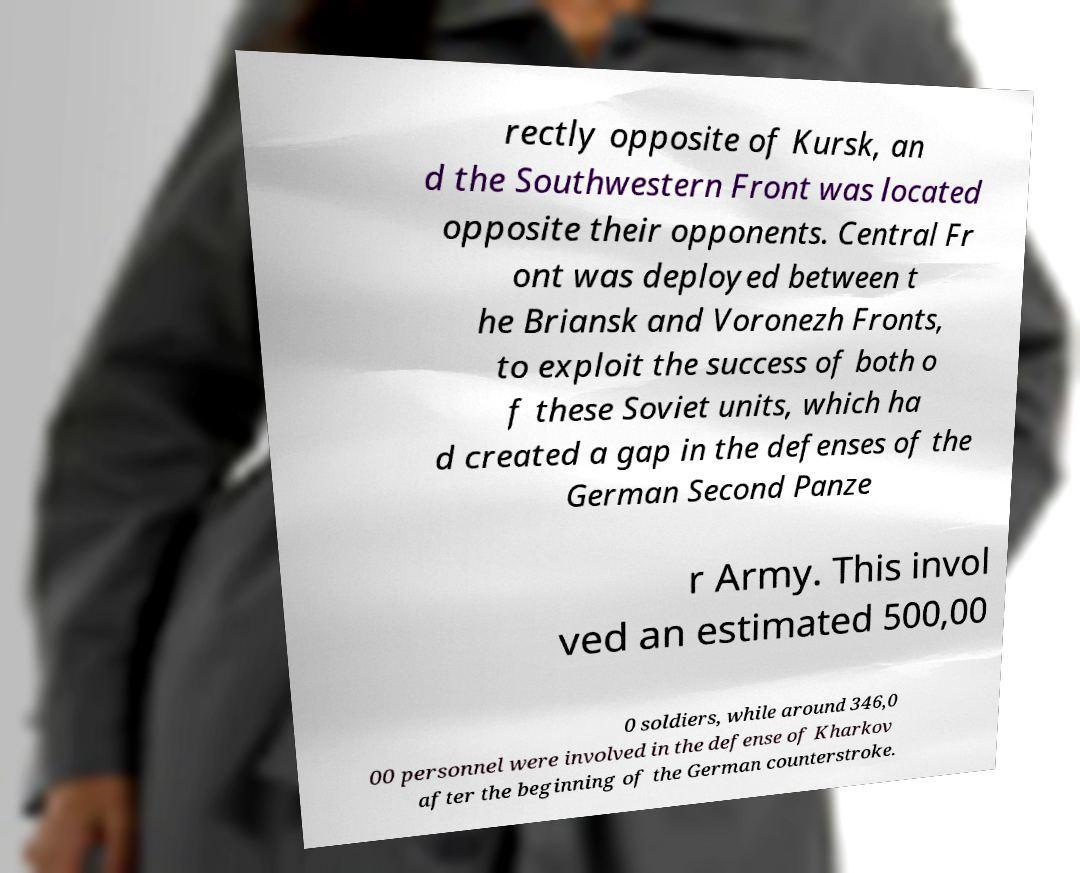Could you assist in decoding the text presented in this image and type it out clearly? rectly opposite of Kursk, an d the Southwestern Front was located opposite their opponents. Central Fr ont was deployed between t he Briansk and Voronezh Fronts, to exploit the success of both o f these Soviet units, which ha d created a gap in the defenses of the German Second Panze r Army. This invol ved an estimated 500,00 0 soldiers, while around 346,0 00 personnel were involved in the defense of Kharkov after the beginning of the German counterstroke. 